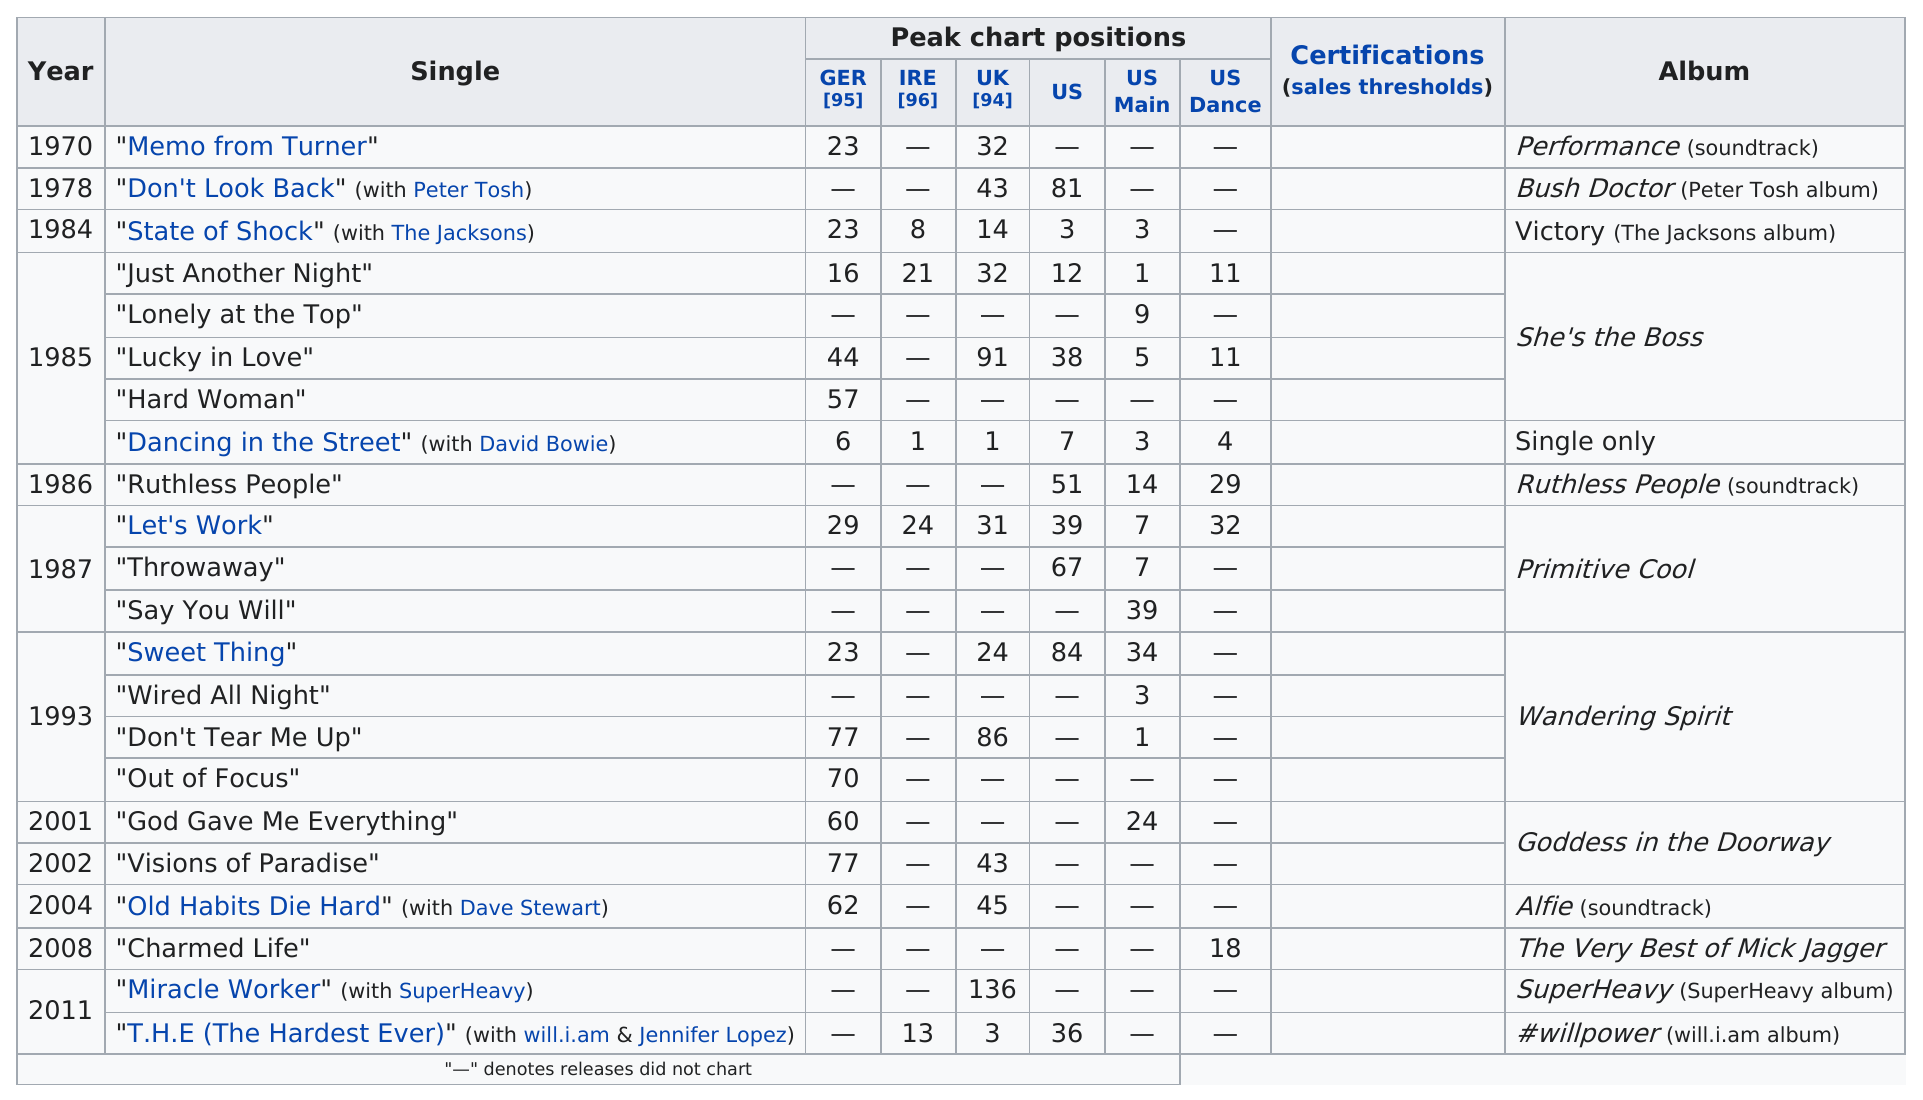Highlight a few significant elements in this photo. The hit single, 'Dancing in the Street' by David Bowie, topped the UK charts but only peaked at #7 in the US. Mick Jagger collaborated with David Bowie on the song "Dancing in the Street. The single with David Bowie reached a chart position of 7 in the US. I name three singles from the album "Wandering Spirit." They are: Sweet Thing, Wired All Night, and Out of Focus. The song "Hard Woman" from the album "She's the Boss" was inspired by the album's creative process and the artist's experience of being a strong and independent woman in a man's world. 